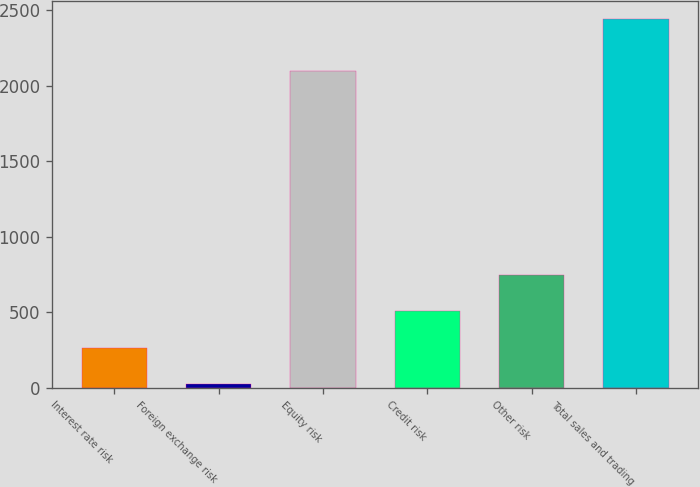<chart> <loc_0><loc_0><loc_500><loc_500><bar_chart><fcel>Interest rate risk<fcel>Foreign exchange risk<fcel>Equity risk<fcel>Credit risk<fcel>Other risk<fcel>Total sales and trading<nl><fcel>267.5<fcel>26<fcel>2094<fcel>509<fcel>750.5<fcel>2441<nl></chart> 